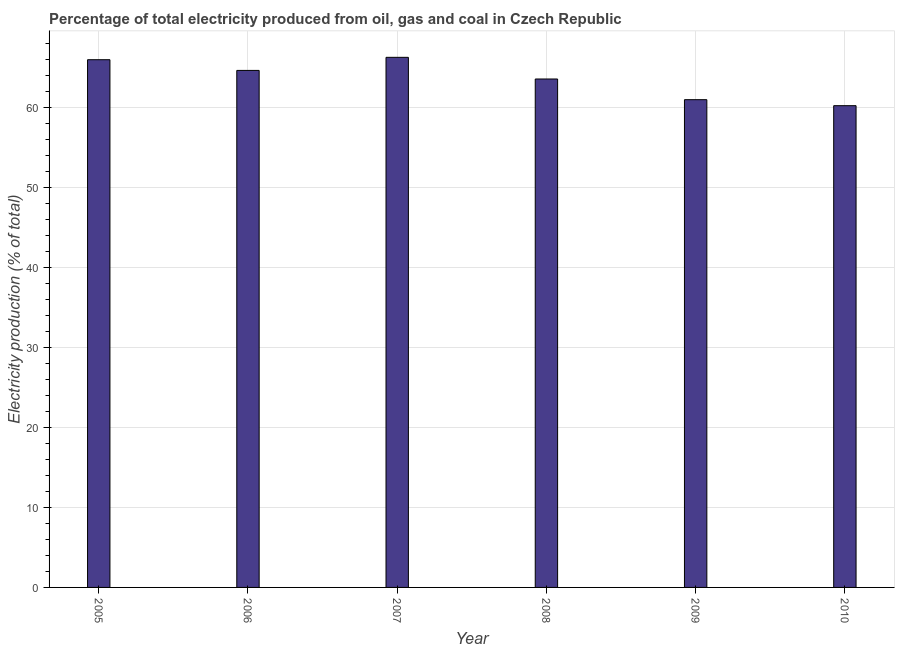Does the graph contain any zero values?
Ensure brevity in your answer.  No. Does the graph contain grids?
Your response must be concise. Yes. What is the title of the graph?
Give a very brief answer. Percentage of total electricity produced from oil, gas and coal in Czech Republic. What is the label or title of the Y-axis?
Keep it short and to the point. Electricity production (% of total). What is the electricity production in 2008?
Your answer should be compact. 63.58. Across all years, what is the maximum electricity production?
Offer a very short reply. 66.28. Across all years, what is the minimum electricity production?
Offer a terse response. 60.24. In which year was the electricity production minimum?
Give a very brief answer. 2010. What is the sum of the electricity production?
Give a very brief answer. 381.72. What is the difference between the electricity production in 2005 and 2010?
Make the answer very short. 5.75. What is the average electricity production per year?
Provide a succinct answer. 63.62. What is the median electricity production?
Offer a very short reply. 64.11. In how many years, is the electricity production greater than 32 %?
Your answer should be very brief. 6. What is the ratio of the electricity production in 2005 to that in 2008?
Ensure brevity in your answer.  1.04. Is the electricity production in 2006 less than that in 2007?
Offer a very short reply. Yes. What is the difference between the highest and the second highest electricity production?
Your answer should be very brief. 0.3. What is the difference between the highest and the lowest electricity production?
Your response must be concise. 6.05. In how many years, is the electricity production greater than the average electricity production taken over all years?
Your answer should be very brief. 3. How many bars are there?
Your answer should be compact. 6. Are all the bars in the graph horizontal?
Ensure brevity in your answer.  No. What is the Electricity production (% of total) in 2005?
Offer a terse response. 65.99. What is the Electricity production (% of total) of 2006?
Ensure brevity in your answer.  64.65. What is the Electricity production (% of total) of 2007?
Your answer should be compact. 66.28. What is the Electricity production (% of total) in 2008?
Make the answer very short. 63.58. What is the Electricity production (% of total) in 2009?
Provide a succinct answer. 60.99. What is the Electricity production (% of total) of 2010?
Offer a terse response. 60.24. What is the difference between the Electricity production (% of total) in 2005 and 2006?
Provide a short and direct response. 1.34. What is the difference between the Electricity production (% of total) in 2005 and 2007?
Offer a very short reply. -0.3. What is the difference between the Electricity production (% of total) in 2005 and 2008?
Your response must be concise. 2.41. What is the difference between the Electricity production (% of total) in 2005 and 2009?
Give a very brief answer. 5. What is the difference between the Electricity production (% of total) in 2005 and 2010?
Provide a short and direct response. 5.75. What is the difference between the Electricity production (% of total) in 2006 and 2007?
Ensure brevity in your answer.  -1.64. What is the difference between the Electricity production (% of total) in 2006 and 2008?
Give a very brief answer. 1.07. What is the difference between the Electricity production (% of total) in 2006 and 2009?
Offer a terse response. 3.66. What is the difference between the Electricity production (% of total) in 2006 and 2010?
Offer a terse response. 4.41. What is the difference between the Electricity production (% of total) in 2007 and 2008?
Keep it short and to the point. 2.71. What is the difference between the Electricity production (% of total) in 2007 and 2009?
Keep it short and to the point. 5.29. What is the difference between the Electricity production (% of total) in 2007 and 2010?
Offer a terse response. 6.05. What is the difference between the Electricity production (% of total) in 2008 and 2009?
Your answer should be very brief. 2.59. What is the difference between the Electricity production (% of total) in 2008 and 2010?
Provide a succinct answer. 3.34. What is the difference between the Electricity production (% of total) in 2009 and 2010?
Give a very brief answer. 0.75. What is the ratio of the Electricity production (% of total) in 2005 to that in 2006?
Provide a short and direct response. 1.02. What is the ratio of the Electricity production (% of total) in 2005 to that in 2007?
Your answer should be very brief. 1. What is the ratio of the Electricity production (% of total) in 2005 to that in 2008?
Your answer should be very brief. 1.04. What is the ratio of the Electricity production (% of total) in 2005 to that in 2009?
Provide a short and direct response. 1.08. What is the ratio of the Electricity production (% of total) in 2005 to that in 2010?
Your response must be concise. 1.09. What is the ratio of the Electricity production (% of total) in 2006 to that in 2008?
Give a very brief answer. 1.02. What is the ratio of the Electricity production (% of total) in 2006 to that in 2009?
Give a very brief answer. 1.06. What is the ratio of the Electricity production (% of total) in 2006 to that in 2010?
Keep it short and to the point. 1.07. What is the ratio of the Electricity production (% of total) in 2007 to that in 2008?
Give a very brief answer. 1.04. What is the ratio of the Electricity production (% of total) in 2007 to that in 2009?
Offer a terse response. 1.09. What is the ratio of the Electricity production (% of total) in 2008 to that in 2009?
Give a very brief answer. 1.04. What is the ratio of the Electricity production (% of total) in 2008 to that in 2010?
Provide a short and direct response. 1.05. 